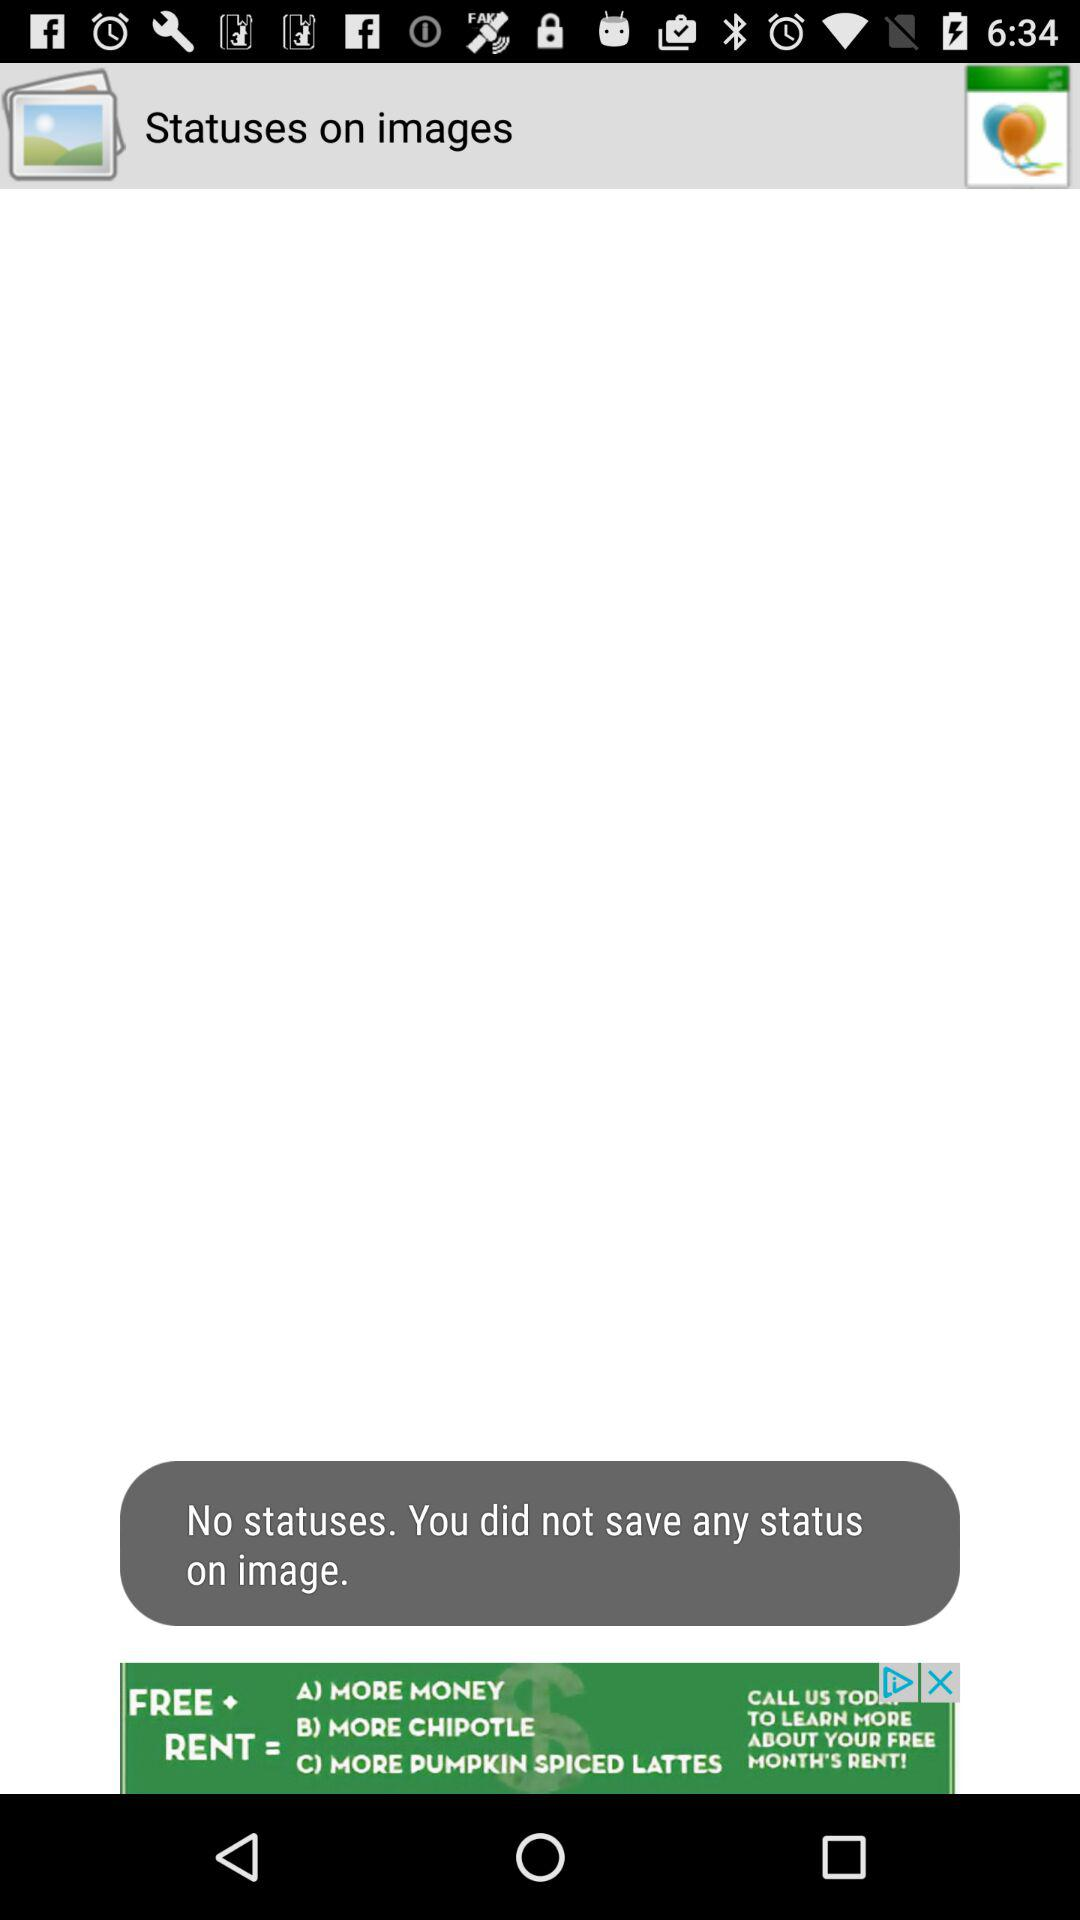Are there any statuses? There are "No" statuses. 